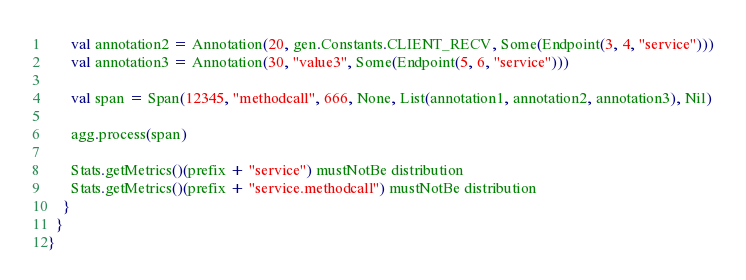Convert code to text. <code><loc_0><loc_0><loc_500><loc_500><_Scala_>      val annotation2 = Annotation(20, gen.Constants.CLIENT_RECV, Some(Endpoint(3, 4, "service")))
      val annotation3 = Annotation(30, "value3", Some(Endpoint(5, 6, "service")))

      val span = Span(12345, "methodcall", 666, None, List(annotation1, annotation2, annotation3), Nil)

      agg.process(span)

      Stats.getMetrics()(prefix + "service") mustNotBe distribution
      Stats.getMetrics()(prefix + "service.methodcall") mustNotBe distribution
    }
  }
}
</code> 